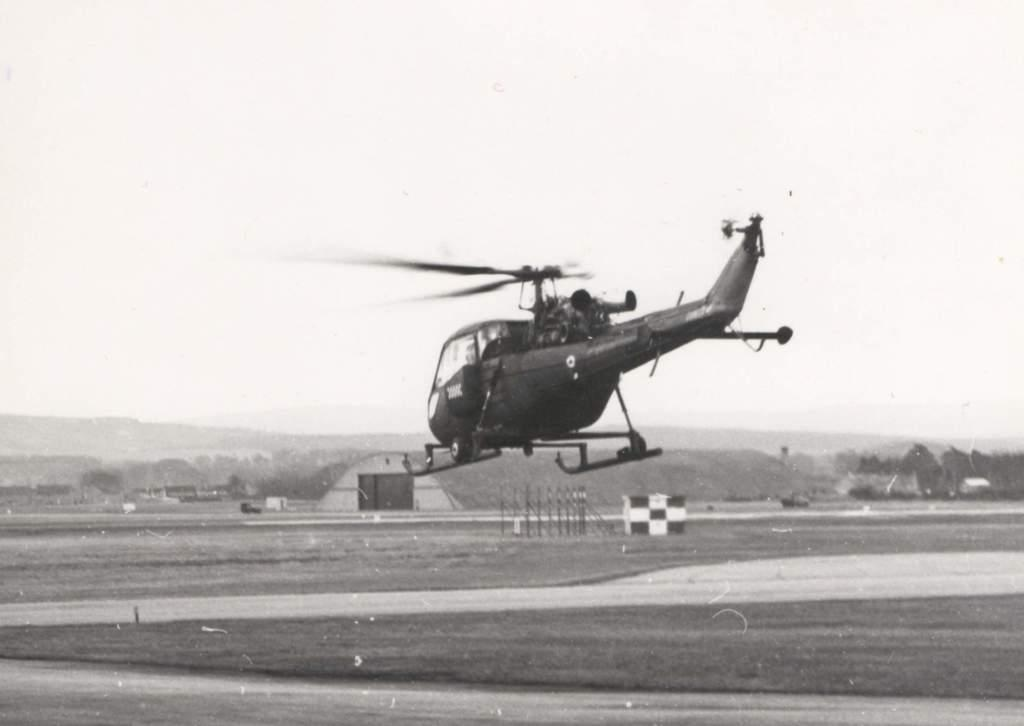What is the main subject in the air in the image? There is a helicopter in the air in the image. What other objects can be seen in the image? There are iron rods visible in the image. Can you see the ocean in the background of the image? There is no reference to an ocean or any body of water in the image, so it cannot be determined if the ocean is visible in the background. 